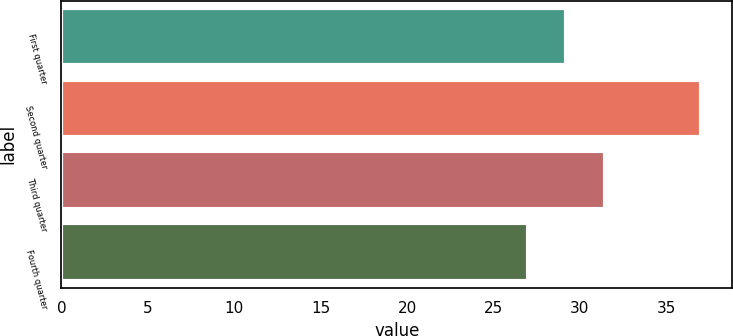Convert chart. <chart><loc_0><loc_0><loc_500><loc_500><bar_chart><fcel>First quarter<fcel>Second quarter<fcel>Third quarter<fcel>Fourth quarter<nl><fcel>29.18<fcel>36.98<fcel>31.46<fcel>27<nl></chart> 